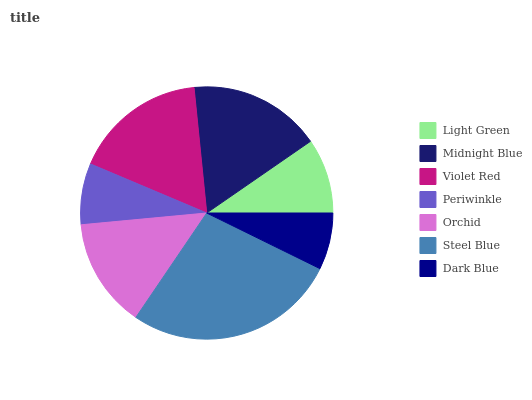Is Dark Blue the minimum?
Answer yes or no. Yes. Is Steel Blue the maximum?
Answer yes or no. Yes. Is Midnight Blue the minimum?
Answer yes or no. No. Is Midnight Blue the maximum?
Answer yes or no. No. Is Midnight Blue greater than Light Green?
Answer yes or no. Yes. Is Light Green less than Midnight Blue?
Answer yes or no. Yes. Is Light Green greater than Midnight Blue?
Answer yes or no. No. Is Midnight Blue less than Light Green?
Answer yes or no. No. Is Orchid the high median?
Answer yes or no. Yes. Is Orchid the low median?
Answer yes or no. Yes. Is Periwinkle the high median?
Answer yes or no. No. Is Violet Red the low median?
Answer yes or no. No. 